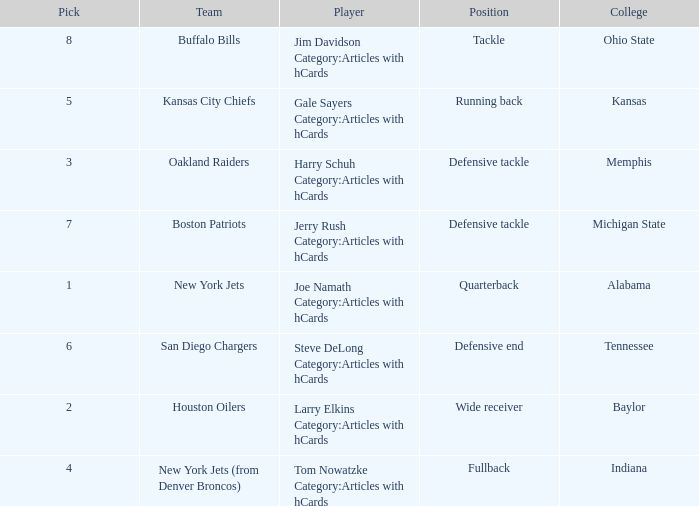The New York Jets picked someone from what college? Alabama. 